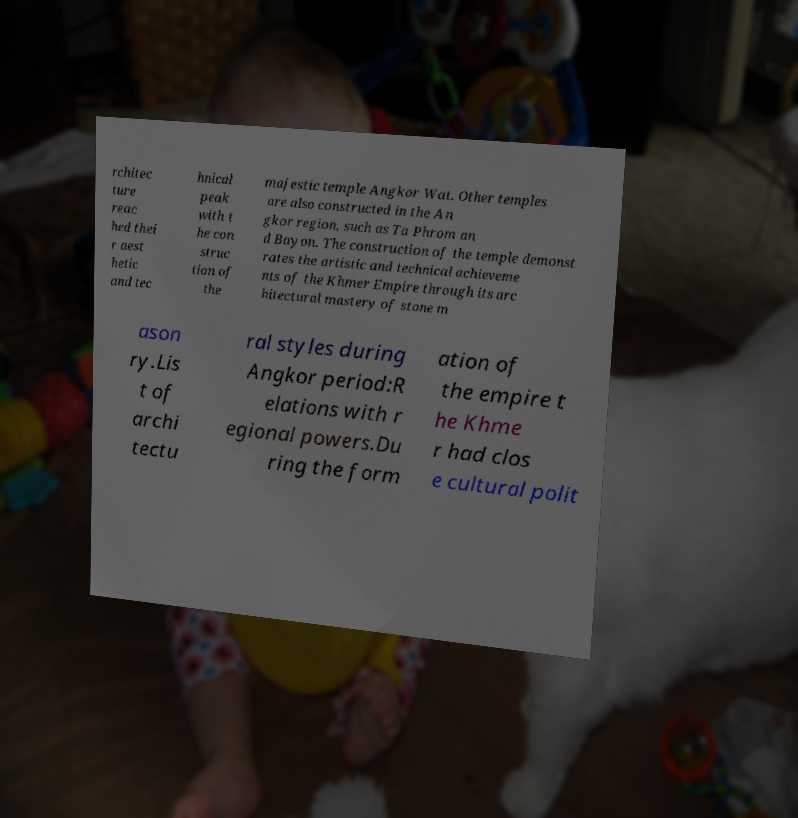Please read and relay the text visible in this image. What does it say? rchitec ture reac hed thei r aest hetic and tec hnical peak with t he con struc tion of the majestic temple Angkor Wat. Other temples are also constructed in the An gkor region, such as Ta Phrom an d Bayon. The construction of the temple demonst rates the artistic and technical achieveme nts of the Khmer Empire through its arc hitectural mastery of stone m ason ry.Lis t of archi tectu ral styles during Angkor period:R elations with r egional powers.Du ring the form ation of the empire t he Khme r had clos e cultural polit 